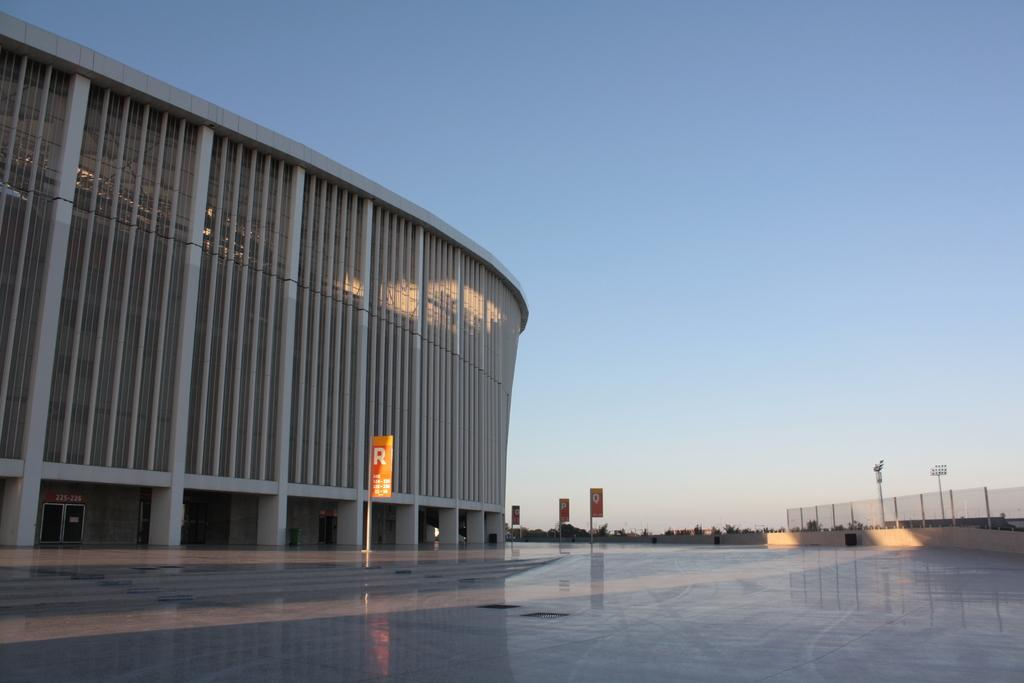What structure is located on the left side of the image? There is a building on the left side of the image. What can be seen near the building? There are boards visible near the building. What is on the right side of the image? There is a fence on the right side of the image. What type of vegetation is visible in the background of the image? There are trees in the background of the image. What is visible in the background of the image besides the trees? The sky is visible in the background of the image. What is at the bottom of the image? There is a floor at the bottom of the image. Can you see a yam being used as a doorstop in the image? There is no yam present in the image, and therefore no such object is being used as a doorstop. Are there any rocks visible in the image? There is no mention of rocks in the provided facts, and no rocks are visible in the image. 